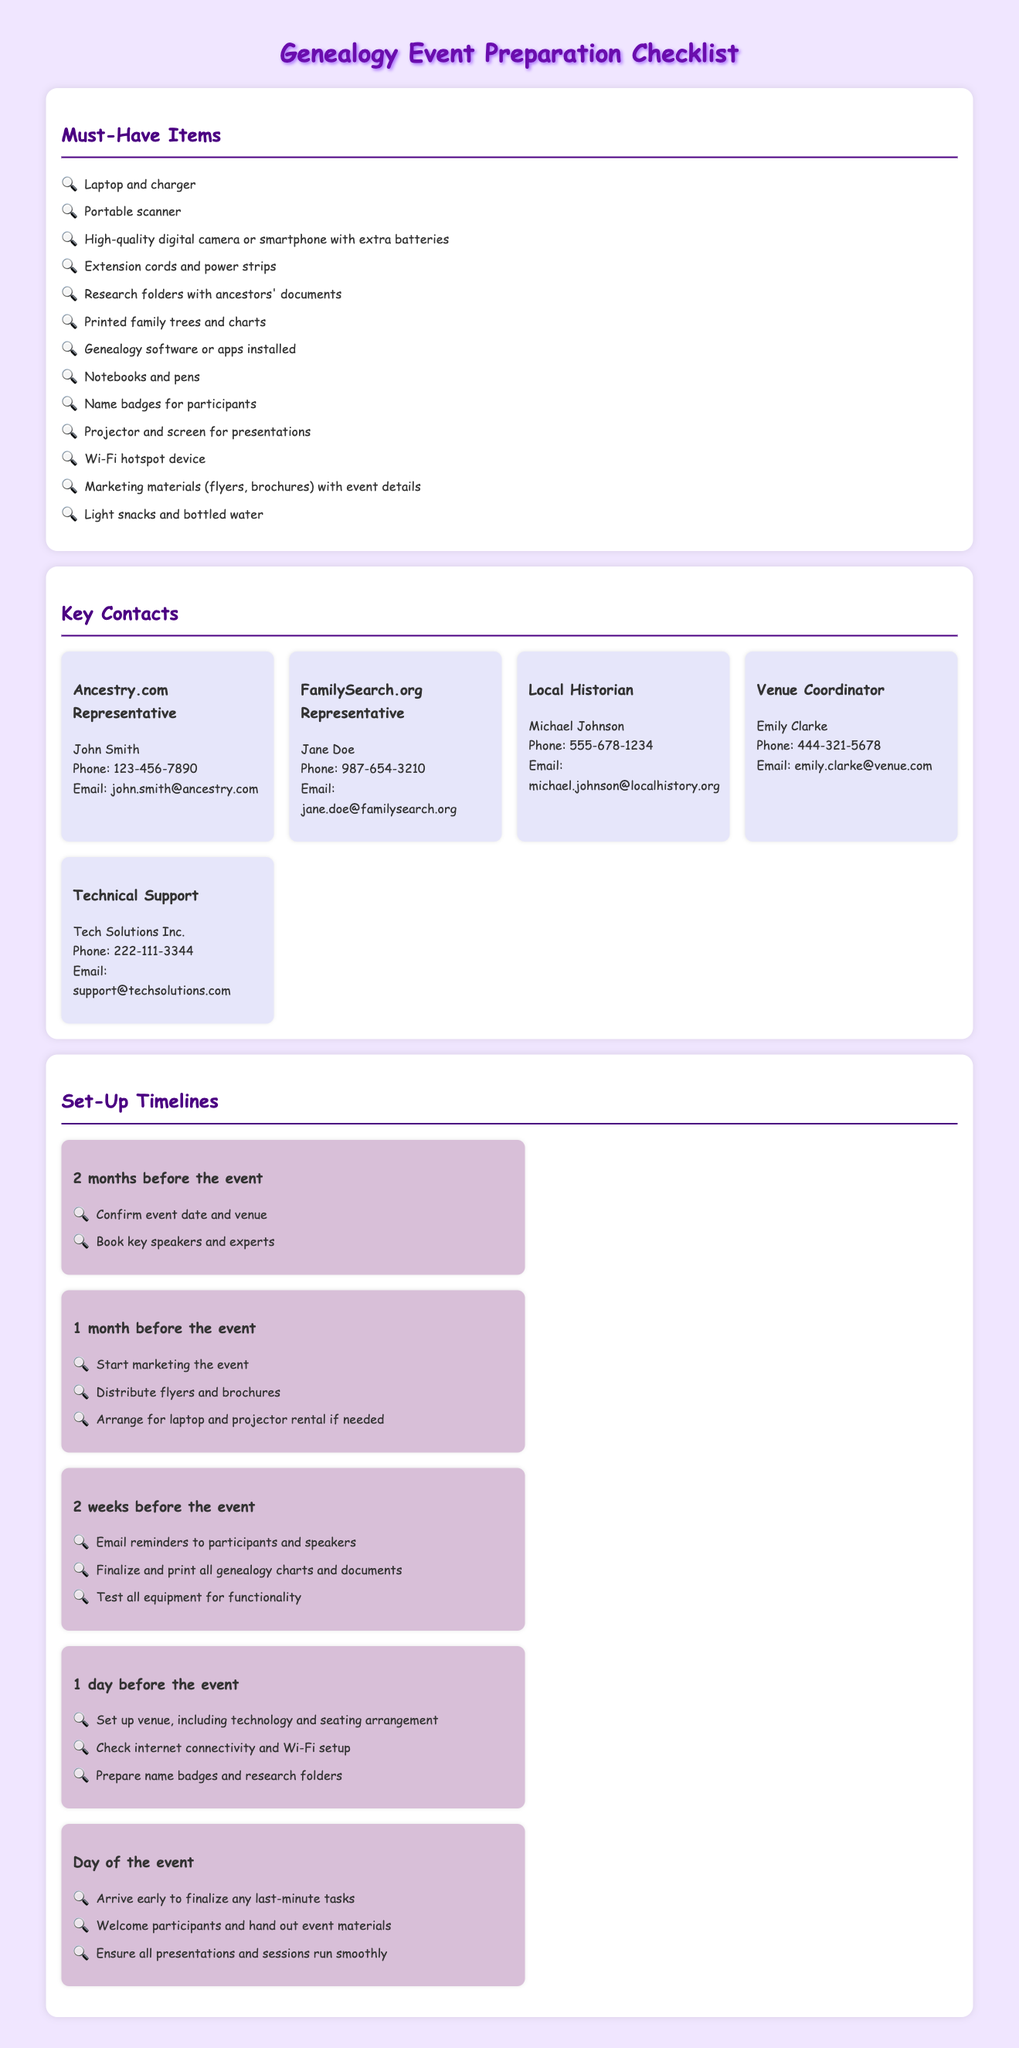What are three must-have items for the event? The must-have items include Laptop and charger, Portable scanner, and High-quality digital camera or smartphone with extra batteries.
Answer: Laptop and charger, Portable scanner, High-quality digital camera or smartphone with extra batteries Who is the contact person for FamilySearch.org? The document lists Jane Doe as the FamilySearch.org contact person.
Answer: Jane Doe How many weeks before the event should you send email reminders? Email reminders should be sent 2 weeks before the event according to the timeline section.
Answer: 2 weeks What should be confirmed 2 months before the event? The confirmation of the event date and venue is required 2 months before the event.
Answer: Event date and venue What is one task to complete on the day of the event? One task to complete on the day of the event is to arrive early to finalize any last-minute tasks.
Answer: Arrive early to finalize any last-minute tasks What is the primary purpose of the checklist document? The checklist document serves as a guide to prepare for a genealogy event including must-have items, key contacts, and setup timelines.
Answer: Prepare for a genealogy event How many different key contacts are listed in the document? There are 5 different key contacts listed in the Contacts section of the document.
Answer: 5 Which month should marketing materials be distributed? Marketing materials should be distributed 1 month before the event according to the timeline.
Answer: 1 month 